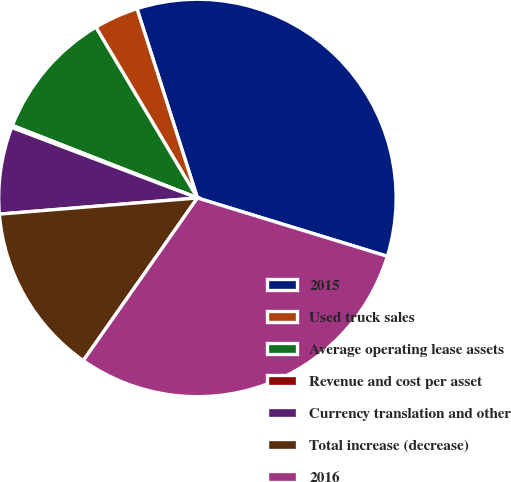<chart> <loc_0><loc_0><loc_500><loc_500><pie_chart><fcel>2015<fcel>Used truck sales<fcel>Average operating lease assets<fcel>Revenue and cost per asset<fcel>Currency translation and other<fcel>Total increase (decrease)<fcel>2016<nl><fcel>34.67%<fcel>3.62%<fcel>10.52%<fcel>0.17%<fcel>7.07%<fcel>13.97%<fcel>30.0%<nl></chart> 